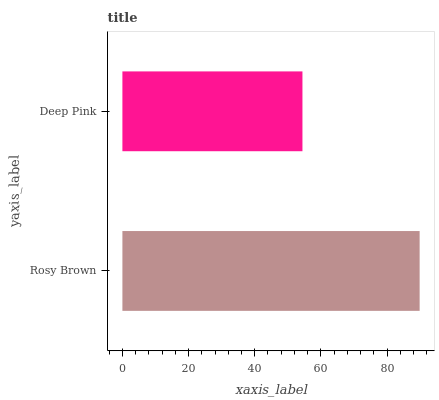Is Deep Pink the minimum?
Answer yes or no. Yes. Is Rosy Brown the maximum?
Answer yes or no. Yes. Is Deep Pink the maximum?
Answer yes or no. No. Is Rosy Brown greater than Deep Pink?
Answer yes or no. Yes. Is Deep Pink less than Rosy Brown?
Answer yes or no. Yes. Is Deep Pink greater than Rosy Brown?
Answer yes or no. No. Is Rosy Brown less than Deep Pink?
Answer yes or no. No. Is Rosy Brown the high median?
Answer yes or no. Yes. Is Deep Pink the low median?
Answer yes or no. Yes. Is Deep Pink the high median?
Answer yes or no. No. Is Rosy Brown the low median?
Answer yes or no. No. 